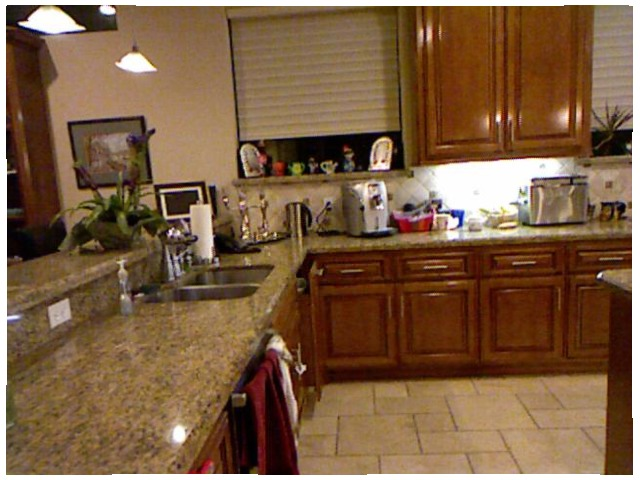<image>
Is there a light under the washbasin? No. The light is not positioned under the washbasin. The vertical relationship between these objects is different. Is there a counter on the towel? No. The counter is not positioned on the towel. They may be near each other, but the counter is not supported by or resting on top of the towel. Is there a picture to the right of the flower? No. The picture is not to the right of the flower. The horizontal positioning shows a different relationship. 